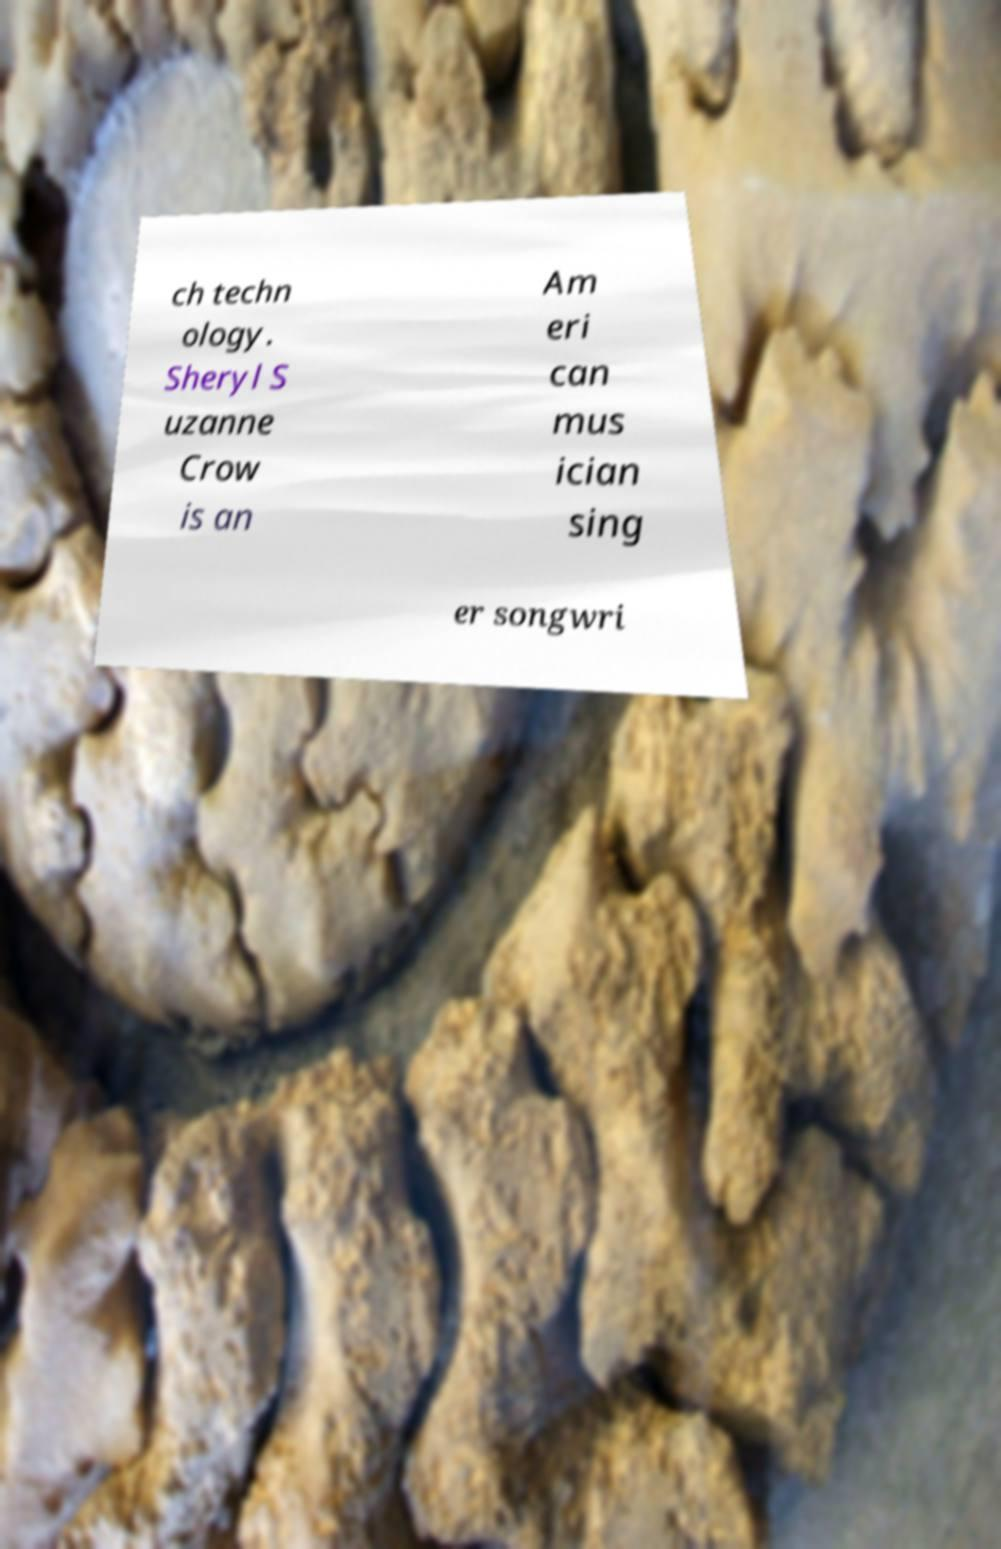Could you assist in decoding the text presented in this image and type it out clearly? ch techn ology. Sheryl S uzanne Crow is an Am eri can mus ician sing er songwri 